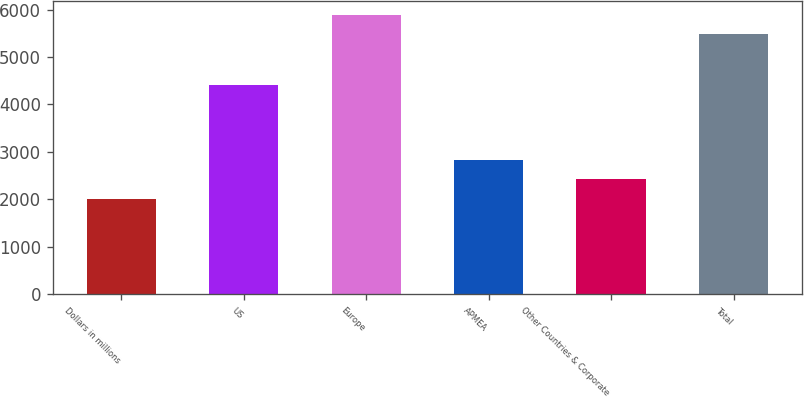Convert chart to OTSL. <chart><loc_0><loc_0><loc_500><loc_500><bar_chart><fcel>Dollars in millions<fcel>US<fcel>Europe<fcel>APMEA<fcel>Other Countries & Corporate<fcel>Total<nl><fcel>2006<fcel>4410<fcel>5885<fcel>2820.9<fcel>2433<fcel>5493<nl></chart> 